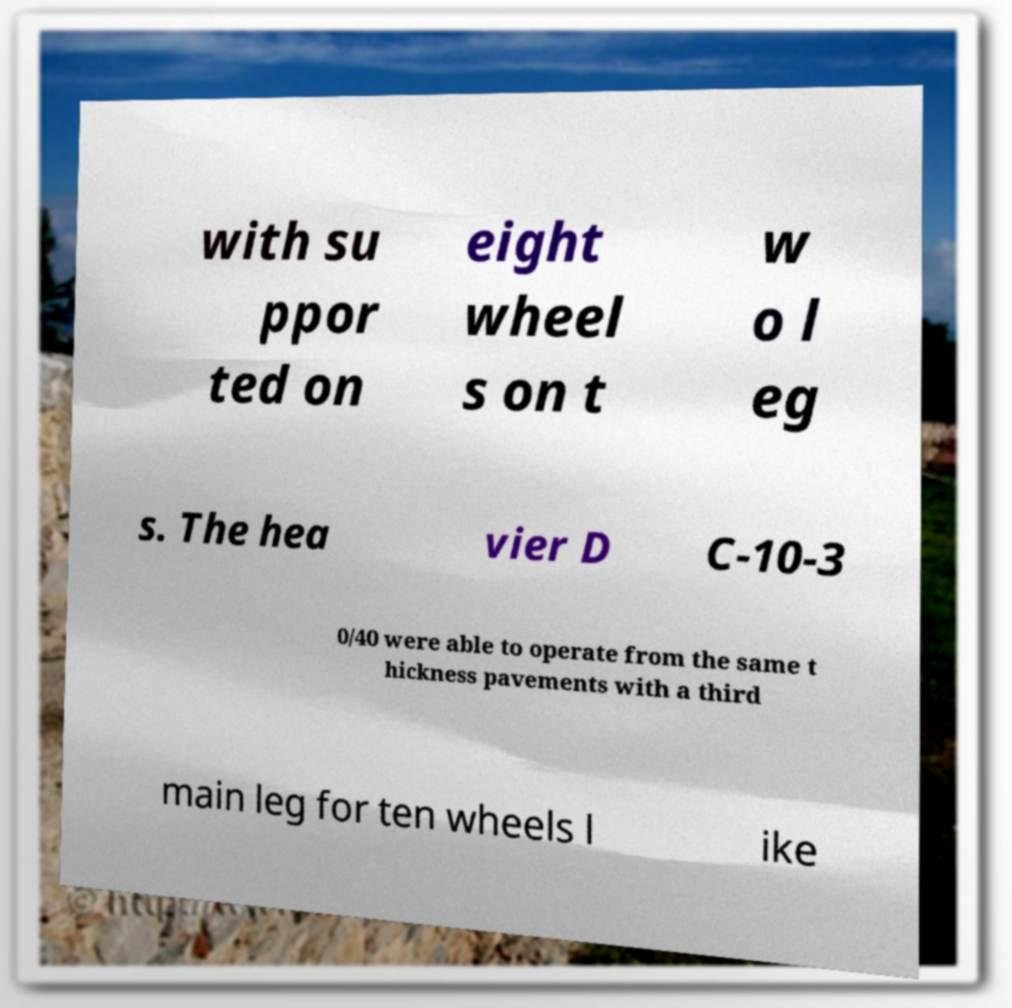Can you read and provide the text displayed in the image?This photo seems to have some interesting text. Can you extract and type it out for me? with su ppor ted on eight wheel s on t w o l eg s. The hea vier D C-10-3 0/40 were able to operate from the same t hickness pavements with a third main leg for ten wheels l ike 